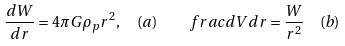<formula> <loc_0><loc_0><loc_500><loc_500>\frac { d W } { d r } = 4 \pi G \rho _ { p } r ^ { 2 } , \ \ ( a ) \quad f r a c { d V } { d r } = \frac { W } { r ^ { 2 } } \ \ ( b )</formula> 